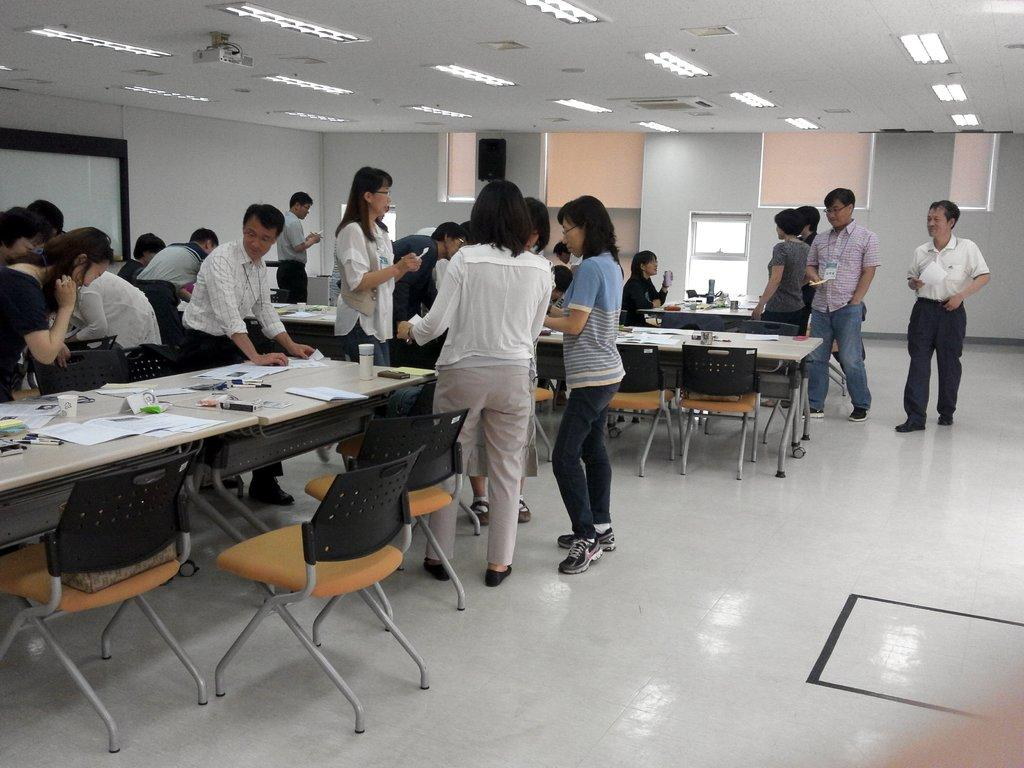How many people are present in the room? There are many people in the room. What type of furniture is present in the room? There are tables and chairs in the room. Where is the projector located in the room? The projector is in the ceiling. What items can be seen on the table? There are papers on the table. Can you tell me how many kitties are playing with a receipt on the table? There are no kitties or receipts present on the table in the image. What type of appliance is being used by the people in the room? The provided facts do not mention any appliances being used by the people in the room. 